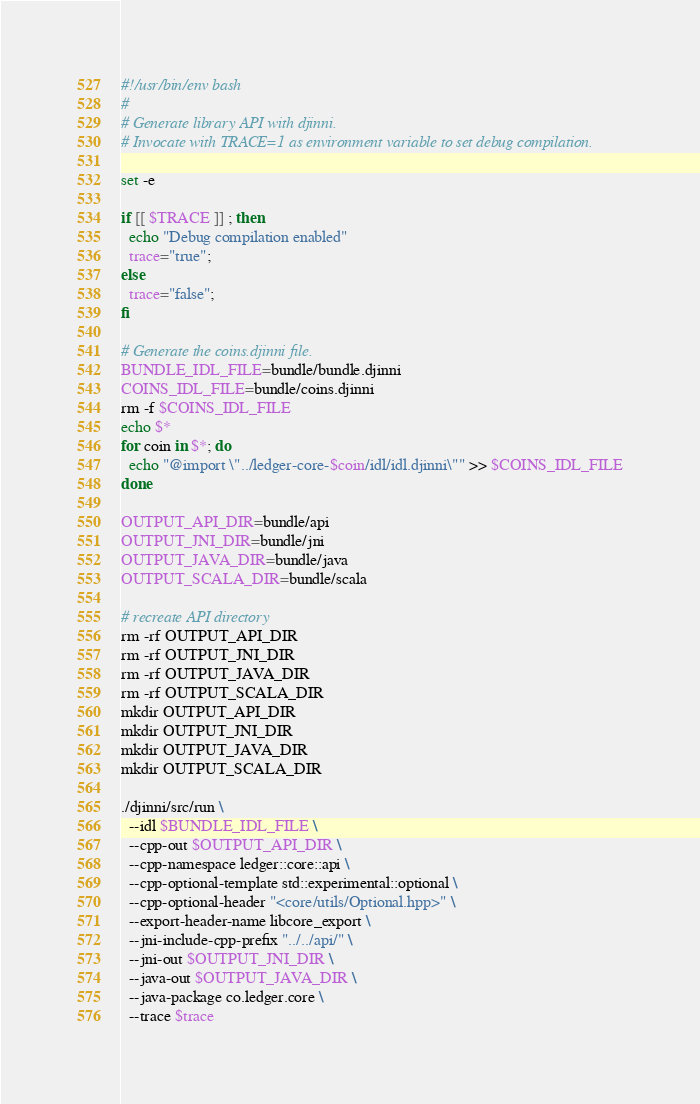<code> <loc_0><loc_0><loc_500><loc_500><_Bash_>#!/usr/bin/env bash
#
# Generate library API with djinni.
# Invocate with TRACE=1 as environment variable to set debug compilation.

set -e

if [[ $TRACE ]] ; then
  echo "Debug compilation enabled"
  trace="true";
else
  trace="false";
fi

# Generate the coins.djinni file.
BUNDLE_IDL_FILE=bundle/bundle.djinni
COINS_IDL_FILE=bundle/coins.djinni
rm -f $COINS_IDL_FILE
echo $*
for coin in $*; do
  echo "@import \"../ledger-core-$coin/idl/idl.djinni\"" >> $COINS_IDL_FILE
done

OUTPUT_API_DIR=bundle/api
OUTPUT_JNI_DIR=bundle/jni
OUTPUT_JAVA_DIR=bundle/java
OUTPUT_SCALA_DIR=bundle/scala

# recreate API directory
rm -rf OUTPUT_API_DIR
rm -rf OUTPUT_JNI_DIR
rm -rf OUTPUT_JAVA_DIR
rm -rf OUTPUT_SCALA_DIR
mkdir OUTPUT_API_DIR
mkdir OUTPUT_JNI_DIR
mkdir OUTPUT_JAVA_DIR
mkdir OUTPUT_SCALA_DIR

./djinni/src/run \
  --idl $BUNDLE_IDL_FILE \
  --cpp-out $OUTPUT_API_DIR \
  --cpp-namespace ledger::core::api \
  --cpp-optional-template std::experimental::optional \
  --cpp-optional-header "<core/utils/Optional.hpp>" \
  --export-header-name libcore_export \
  --jni-include-cpp-prefix "../../api/" \
  --jni-out $OUTPUT_JNI_DIR \
  --java-out $OUTPUT_JAVA_DIR \
  --java-package co.ledger.core \
  --trace $trace
</code> 